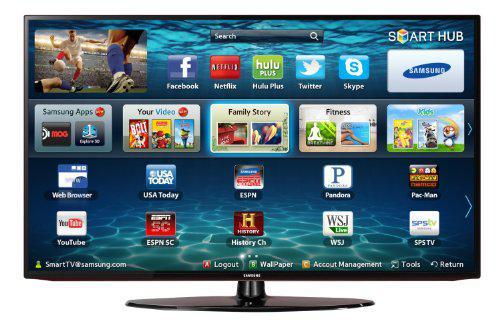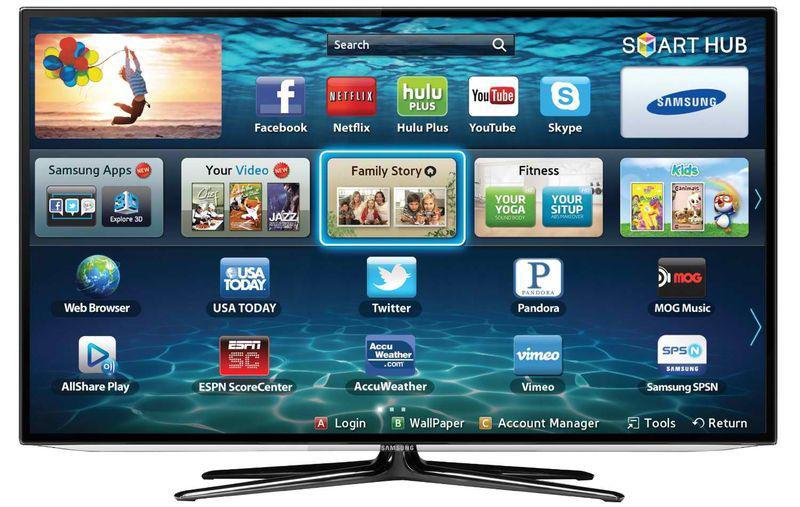The first image is the image on the left, the second image is the image on the right. Evaluate the accuracy of this statement regarding the images: "Each image shows a head-on view of one flat-screen TV on a short black stand, and each TV screen displays a watery blue scene.". Is it true? Answer yes or no. Yes. The first image is the image on the left, the second image is the image on the right. Assess this claim about the two images: "One television has a pair of end stands.". Correct or not? Answer yes or no. No. 